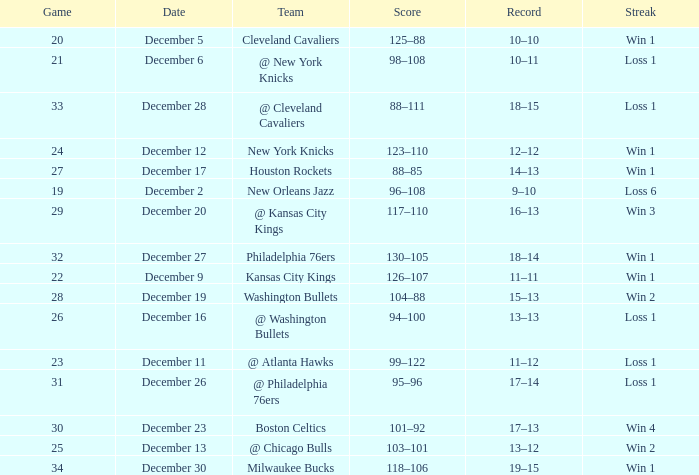What Game had a Score of 101–92? 30.0. 